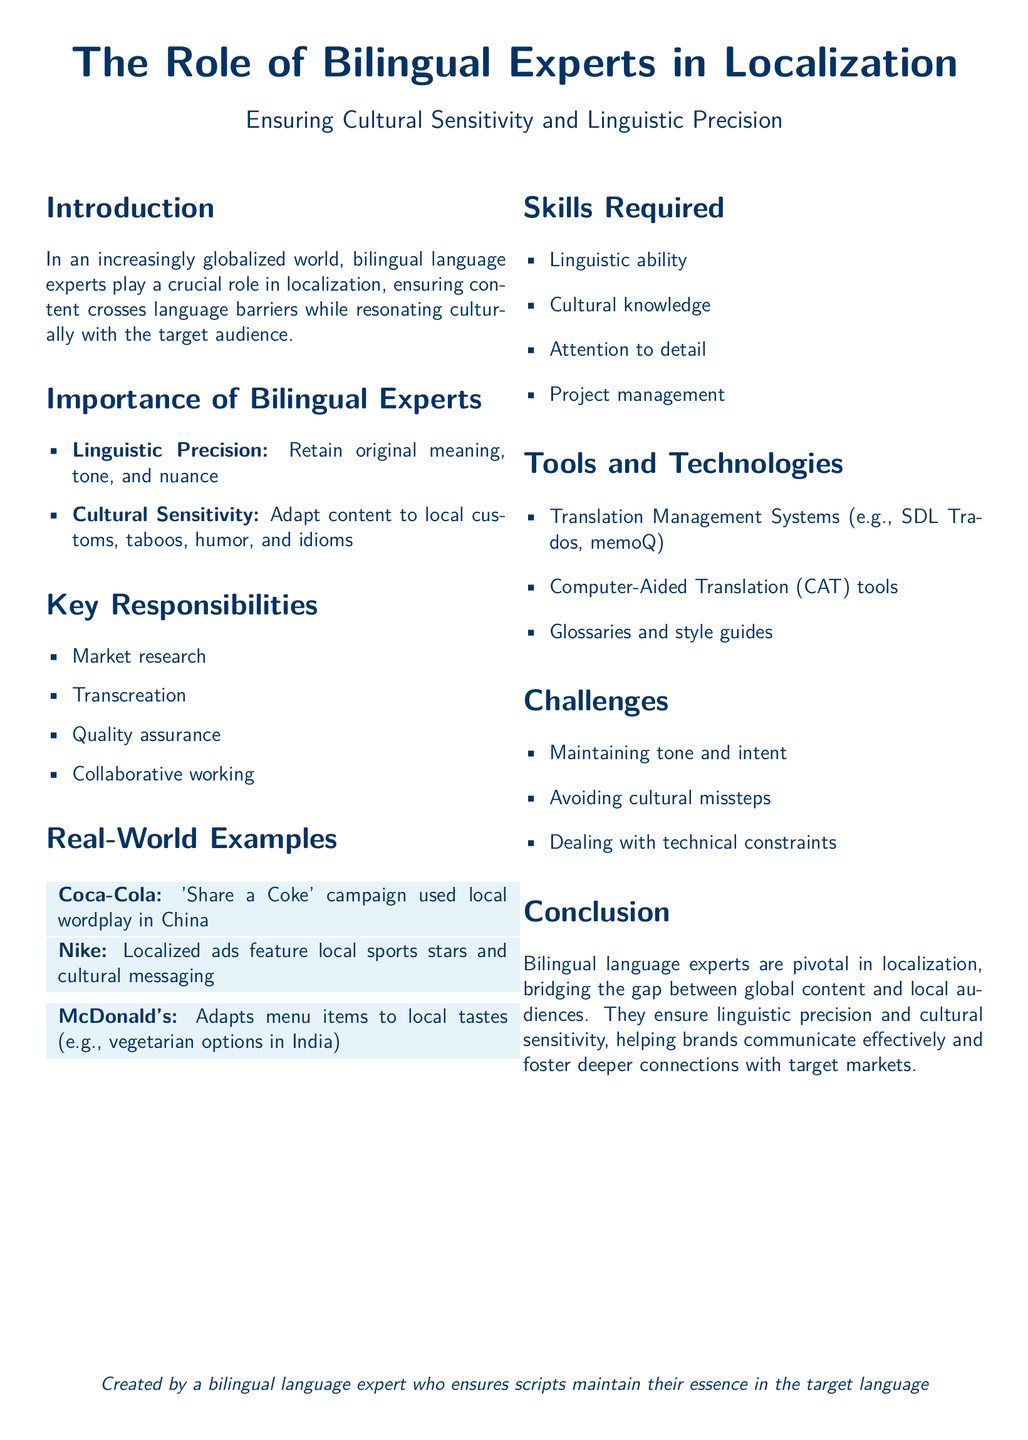What is the title of the document? The title of the document is the main heading at the top of the rendered output.
Answer: The Role of Bilingual Experts in Localization What is the main focus of bilingual experts in localization? The main focus is outlined in the subtitle that follows the title, specifying their role in relation to culture and language.
Answer: Ensuring Cultural Sensitivity and Linguistic Precision Name one key responsibility of bilingual experts. The document lists several key responsibilities, with each one presented in bullet points.
Answer: Market research Which brand's campaign used local wordplay in China? The example provided in the factbox section mentions a specific brand and its campaign that illustrates local adaptation.
Answer: Coca-Cola What is one skill required for bilingual experts? The document highlights several skills under the 'Skills Required' section itemized for direct reference.
Answer: Linguistic ability List one tool mentioned for bilingual experts. Tools and technologies are specified under their respective section, and each tool mentioned serves a function in the localization process.
Answer: SDL Trados What challenge do bilingual experts face related to cultural sensitivity? A specific challenge is mentioned related to cultural aspects, communicated through bullet points in the document.
Answer: Avoiding cultural missteps How does McDonald's adapt to local markets according to the document? The document provides a specific example in the 'Real-World Examples' section that shows this adaptation.
Answer: Adapts menu items to local tastes What is emphasized in the conclusion about the role of bilingual experts? The conclusion summarizes the overall importance of a specific group elaborated earlier in the document.
Answer: They ensure linguistic precision and cultural sensitivity 